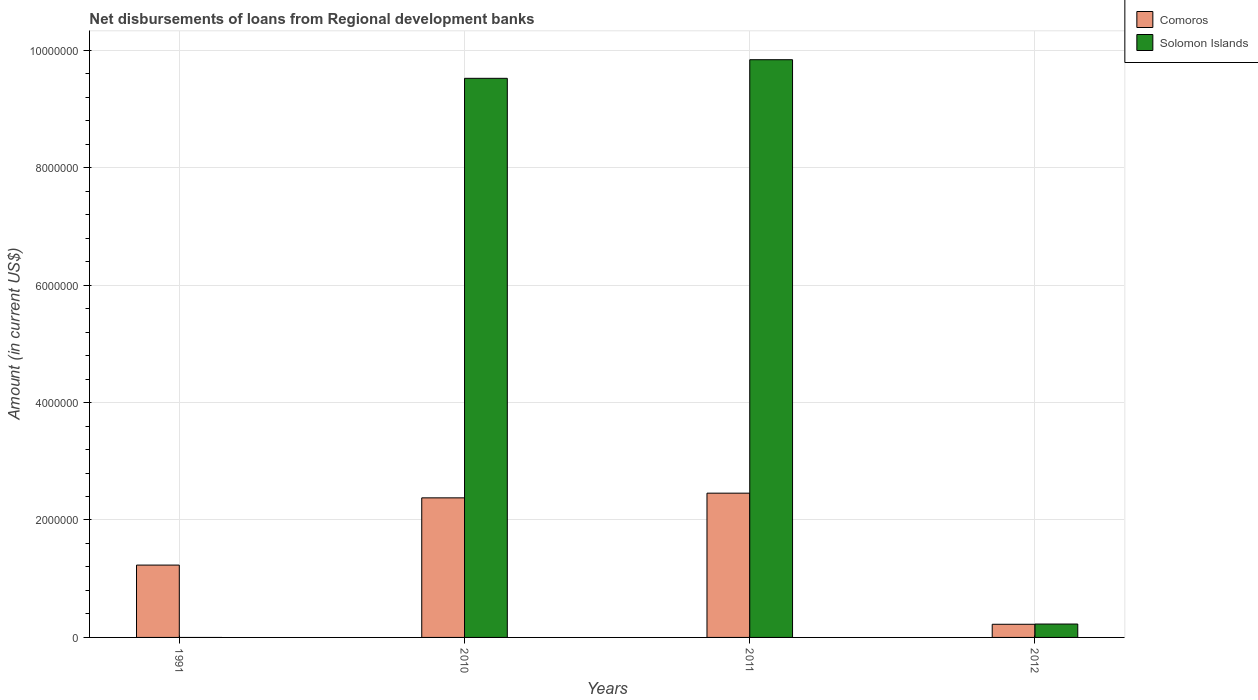How many different coloured bars are there?
Ensure brevity in your answer.  2. How many bars are there on the 1st tick from the left?
Ensure brevity in your answer.  1. In how many cases, is the number of bars for a given year not equal to the number of legend labels?
Make the answer very short. 1. What is the amount of disbursements of loans from regional development banks in Solomon Islands in 2012?
Keep it short and to the point. 2.28e+05. Across all years, what is the maximum amount of disbursements of loans from regional development banks in Solomon Islands?
Your answer should be very brief. 9.84e+06. Across all years, what is the minimum amount of disbursements of loans from regional development banks in Solomon Islands?
Keep it short and to the point. 0. What is the total amount of disbursements of loans from regional development banks in Solomon Islands in the graph?
Make the answer very short. 1.96e+07. What is the difference between the amount of disbursements of loans from regional development banks in Comoros in 2010 and that in 2012?
Keep it short and to the point. 2.15e+06. What is the difference between the amount of disbursements of loans from regional development banks in Solomon Islands in 2010 and the amount of disbursements of loans from regional development banks in Comoros in 2012?
Offer a very short reply. 9.30e+06. What is the average amount of disbursements of loans from regional development banks in Comoros per year?
Your answer should be compact. 1.57e+06. In the year 2010, what is the difference between the amount of disbursements of loans from regional development banks in Solomon Islands and amount of disbursements of loans from regional development banks in Comoros?
Your response must be concise. 7.14e+06. Is the difference between the amount of disbursements of loans from regional development banks in Solomon Islands in 2010 and 2012 greater than the difference between the amount of disbursements of loans from regional development banks in Comoros in 2010 and 2012?
Provide a succinct answer. Yes. What is the difference between the highest and the second highest amount of disbursements of loans from regional development banks in Solomon Islands?
Your answer should be very brief. 3.17e+05. What is the difference between the highest and the lowest amount of disbursements of loans from regional development banks in Comoros?
Provide a succinct answer. 2.23e+06. How many bars are there?
Keep it short and to the point. 7. Are all the bars in the graph horizontal?
Ensure brevity in your answer.  No. How many years are there in the graph?
Ensure brevity in your answer.  4. Where does the legend appear in the graph?
Your response must be concise. Top right. What is the title of the graph?
Make the answer very short. Net disbursements of loans from Regional development banks. Does "Switzerland" appear as one of the legend labels in the graph?
Your response must be concise. No. What is the label or title of the X-axis?
Ensure brevity in your answer.  Years. What is the Amount (in current US$) of Comoros in 1991?
Offer a very short reply. 1.23e+06. What is the Amount (in current US$) of Solomon Islands in 1991?
Offer a very short reply. 0. What is the Amount (in current US$) in Comoros in 2010?
Your response must be concise. 2.38e+06. What is the Amount (in current US$) of Solomon Islands in 2010?
Provide a short and direct response. 9.52e+06. What is the Amount (in current US$) of Comoros in 2011?
Provide a short and direct response. 2.46e+06. What is the Amount (in current US$) in Solomon Islands in 2011?
Ensure brevity in your answer.  9.84e+06. What is the Amount (in current US$) of Comoros in 2012?
Keep it short and to the point. 2.24e+05. What is the Amount (in current US$) in Solomon Islands in 2012?
Provide a succinct answer. 2.28e+05. Across all years, what is the maximum Amount (in current US$) of Comoros?
Give a very brief answer. 2.46e+06. Across all years, what is the maximum Amount (in current US$) of Solomon Islands?
Your response must be concise. 9.84e+06. Across all years, what is the minimum Amount (in current US$) in Comoros?
Give a very brief answer. 2.24e+05. Across all years, what is the minimum Amount (in current US$) of Solomon Islands?
Offer a terse response. 0. What is the total Amount (in current US$) in Comoros in the graph?
Your answer should be compact. 6.29e+06. What is the total Amount (in current US$) in Solomon Islands in the graph?
Your response must be concise. 1.96e+07. What is the difference between the Amount (in current US$) of Comoros in 1991 and that in 2010?
Your answer should be compact. -1.14e+06. What is the difference between the Amount (in current US$) of Comoros in 1991 and that in 2011?
Your response must be concise. -1.22e+06. What is the difference between the Amount (in current US$) of Comoros in 1991 and that in 2012?
Give a very brief answer. 1.01e+06. What is the difference between the Amount (in current US$) in Comoros in 2010 and that in 2011?
Give a very brief answer. -8.00e+04. What is the difference between the Amount (in current US$) in Solomon Islands in 2010 and that in 2011?
Provide a short and direct response. -3.17e+05. What is the difference between the Amount (in current US$) of Comoros in 2010 and that in 2012?
Provide a succinct answer. 2.15e+06. What is the difference between the Amount (in current US$) in Solomon Islands in 2010 and that in 2012?
Your answer should be very brief. 9.29e+06. What is the difference between the Amount (in current US$) in Comoros in 2011 and that in 2012?
Your answer should be compact. 2.23e+06. What is the difference between the Amount (in current US$) of Solomon Islands in 2011 and that in 2012?
Ensure brevity in your answer.  9.61e+06. What is the difference between the Amount (in current US$) in Comoros in 1991 and the Amount (in current US$) in Solomon Islands in 2010?
Ensure brevity in your answer.  -8.29e+06. What is the difference between the Amount (in current US$) of Comoros in 1991 and the Amount (in current US$) of Solomon Islands in 2011?
Make the answer very short. -8.61e+06. What is the difference between the Amount (in current US$) in Comoros in 1991 and the Amount (in current US$) in Solomon Islands in 2012?
Ensure brevity in your answer.  1.00e+06. What is the difference between the Amount (in current US$) of Comoros in 2010 and the Amount (in current US$) of Solomon Islands in 2011?
Your answer should be compact. -7.46e+06. What is the difference between the Amount (in current US$) of Comoros in 2010 and the Amount (in current US$) of Solomon Islands in 2012?
Keep it short and to the point. 2.15e+06. What is the difference between the Amount (in current US$) in Comoros in 2011 and the Amount (in current US$) in Solomon Islands in 2012?
Keep it short and to the point. 2.23e+06. What is the average Amount (in current US$) in Comoros per year?
Your answer should be very brief. 1.57e+06. What is the average Amount (in current US$) of Solomon Islands per year?
Your response must be concise. 4.90e+06. In the year 2010, what is the difference between the Amount (in current US$) in Comoros and Amount (in current US$) in Solomon Islands?
Ensure brevity in your answer.  -7.14e+06. In the year 2011, what is the difference between the Amount (in current US$) in Comoros and Amount (in current US$) in Solomon Islands?
Ensure brevity in your answer.  -7.38e+06. In the year 2012, what is the difference between the Amount (in current US$) in Comoros and Amount (in current US$) in Solomon Islands?
Provide a short and direct response. -4000. What is the ratio of the Amount (in current US$) of Comoros in 1991 to that in 2010?
Offer a terse response. 0.52. What is the ratio of the Amount (in current US$) of Comoros in 1991 to that in 2011?
Your answer should be very brief. 0.5. What is the ratio of the Amount (in current US$) of Comoros in 2010 to that in 2011?
Give a very brief answer. 0.97. What is the ratio of the Amount (in current US$) of Solomon Islands in 2010 to that in 2011?
Provide a succinct answer. 0.97. What is the ratio of the Amount (in current US$) in Comoros in 2010 to that in 2012?
Offer a terse response. 10.61. What is the ratio of the Amount (in current US$) of Solomon Islands in 2010 to that in 2012?
Your response must be concise. 41.76. What is the ratio of the Amount (in current US$) in Comoros in 2011 to that in 2012?
Your answer should be compact. 10.97. What is the ratio of the Amount (in current US$) of Solomon Islands in 2011 to that in 2012?
Your answer should be compact. 43.15. What is the difference between the highest and the second highest Amount (in current US$) of Comoros?
Offer a very short reply. 8.00e+04. What is the difference between the highest and the second highest Amount (in current US$) in Solomon Islands?
Give a very brief answer. 3.17e+05. What is the difference between the highest and the lowest Amount (in current US$) in Comoros?
Provide a succinct answer. 2.23e+06. What is the difference between the highest and the lowest Amount (in current US$) in Solomon Islands?
Provide a succinct answer. 9.84e+06. 